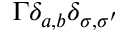Convert formula to latex. <formula><loc_0><loc_0><loc_500><loc_500>\Gamma \delta _ { a , b } \delta _ { \sigma , \sigma ^ { \prime } }</formula> 